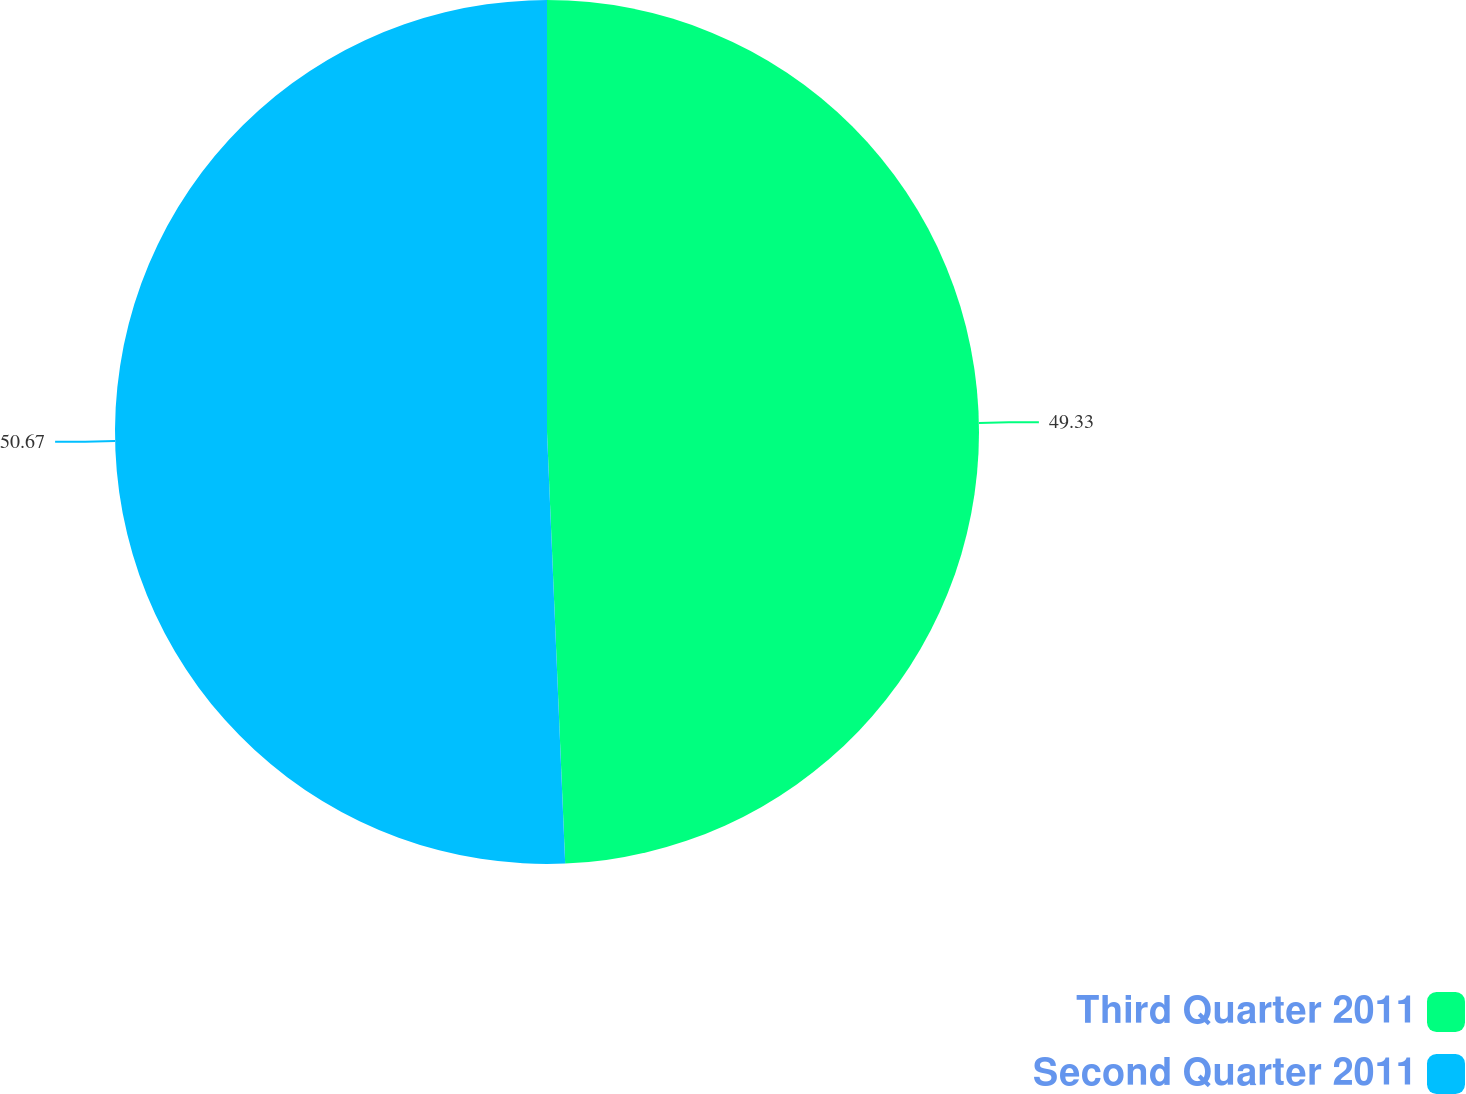Convert chart. <chart><loc_0><loc_0><loc_500><loc_500><pie_chart><fcel>Third Quarter 2011<fcel>Second Quarter 2011<nl><fcel>49.33%<fcel>50.67%<nl></chart> 